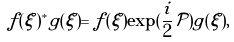Convert formula to latex. <formula><loc_0><loc_0><loc_500><loc_500>f ( \xi ) ^ { * } g ( \xi ) = f ( \xi ) \exp ( \frac { i } { 2 } \mathcal { P } ) g ( \xi ) ,</formula> 